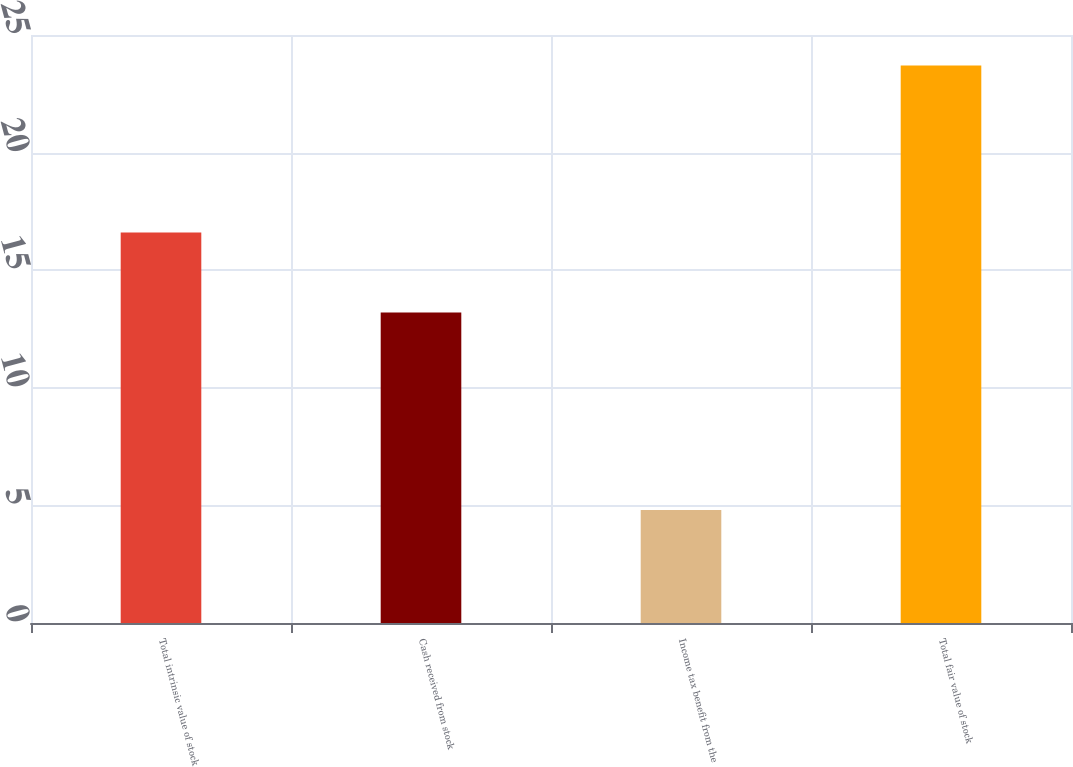Convert chart. <chart><loc_0><loc_0><loc_500><loc_500><bar_chart><fcel>Total intrinsic value of stock<fcel>Cash received from stock<fcel>Income tax benefit from the<fcel>Total fair value of stock<nl><fcel>16.6<fcel>13.2<fcel>4.8<fcel>23.7<nl></chart> 